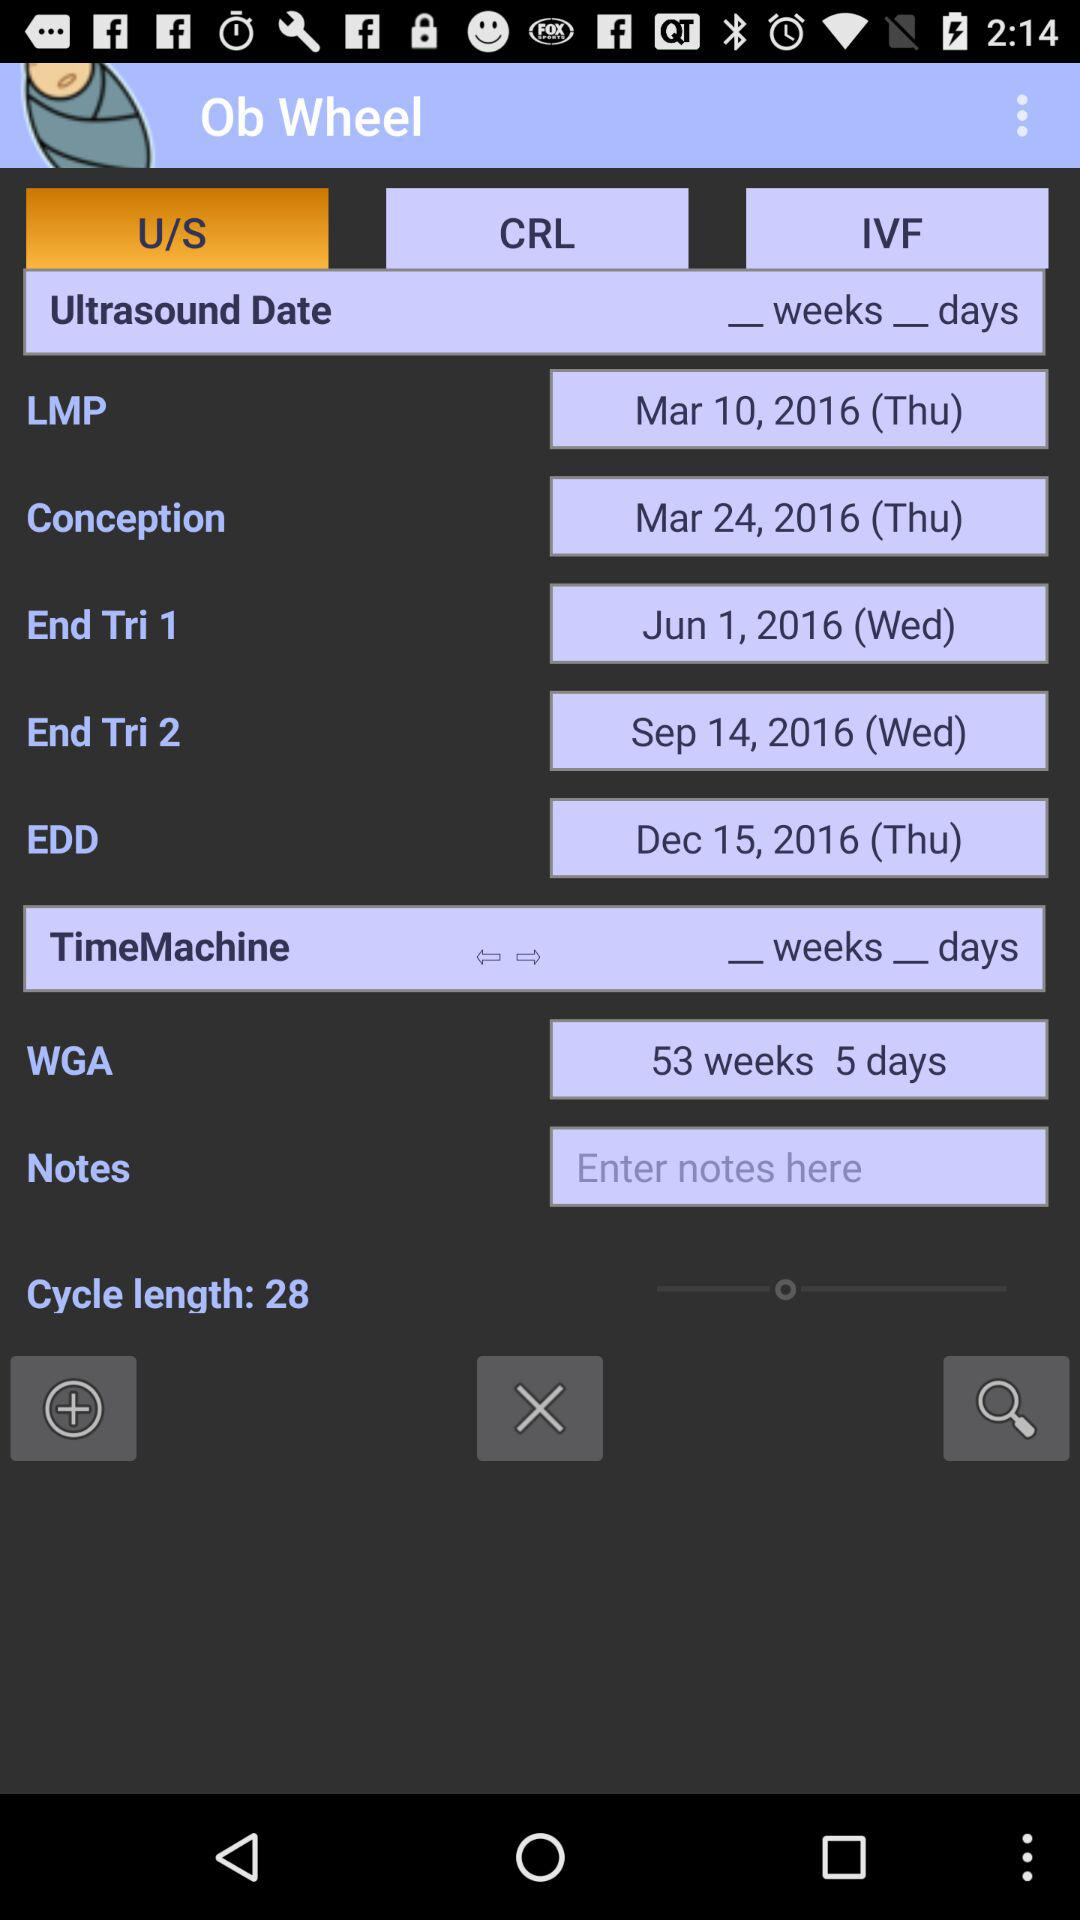Can you explain the term 'WGA' shown in the image? 'WGA' stands for Weeks of Gestational Age. It's a measure of the age of a pregnancy calculated from the gestational age at the woman's last menstrual period. In the image, 'WGA' is 53 weeks and 5 days which seems to be an error as a typical full-term pregnancy is around 40 weeks. 